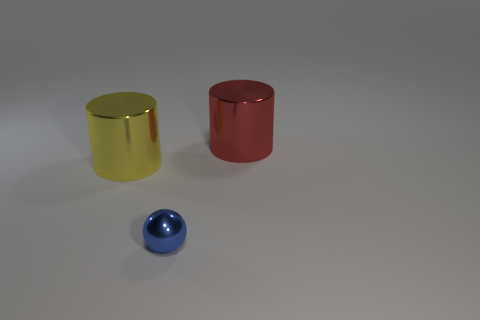What time of day does the lighting in this scene suggest? The lighting in the scene appears to be artificial and controlled, suggesting it's set up in a studio environment rather than being indicative of a natural time of day. 